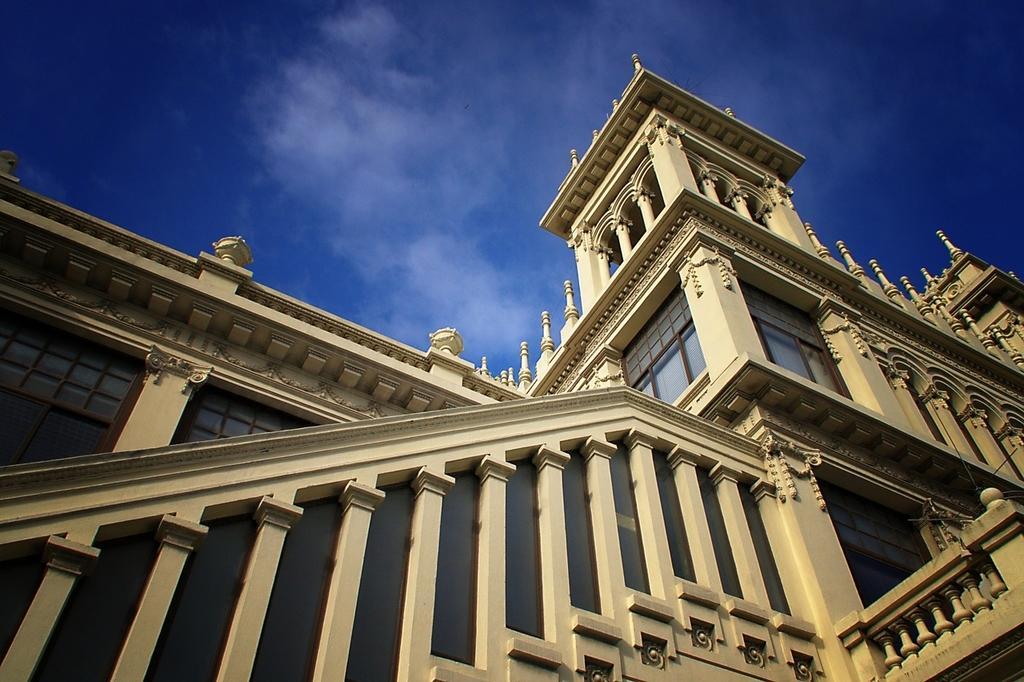Could you give a brief overview of what you see in this image? In this image we can see a building. At the top we can see the sky. 